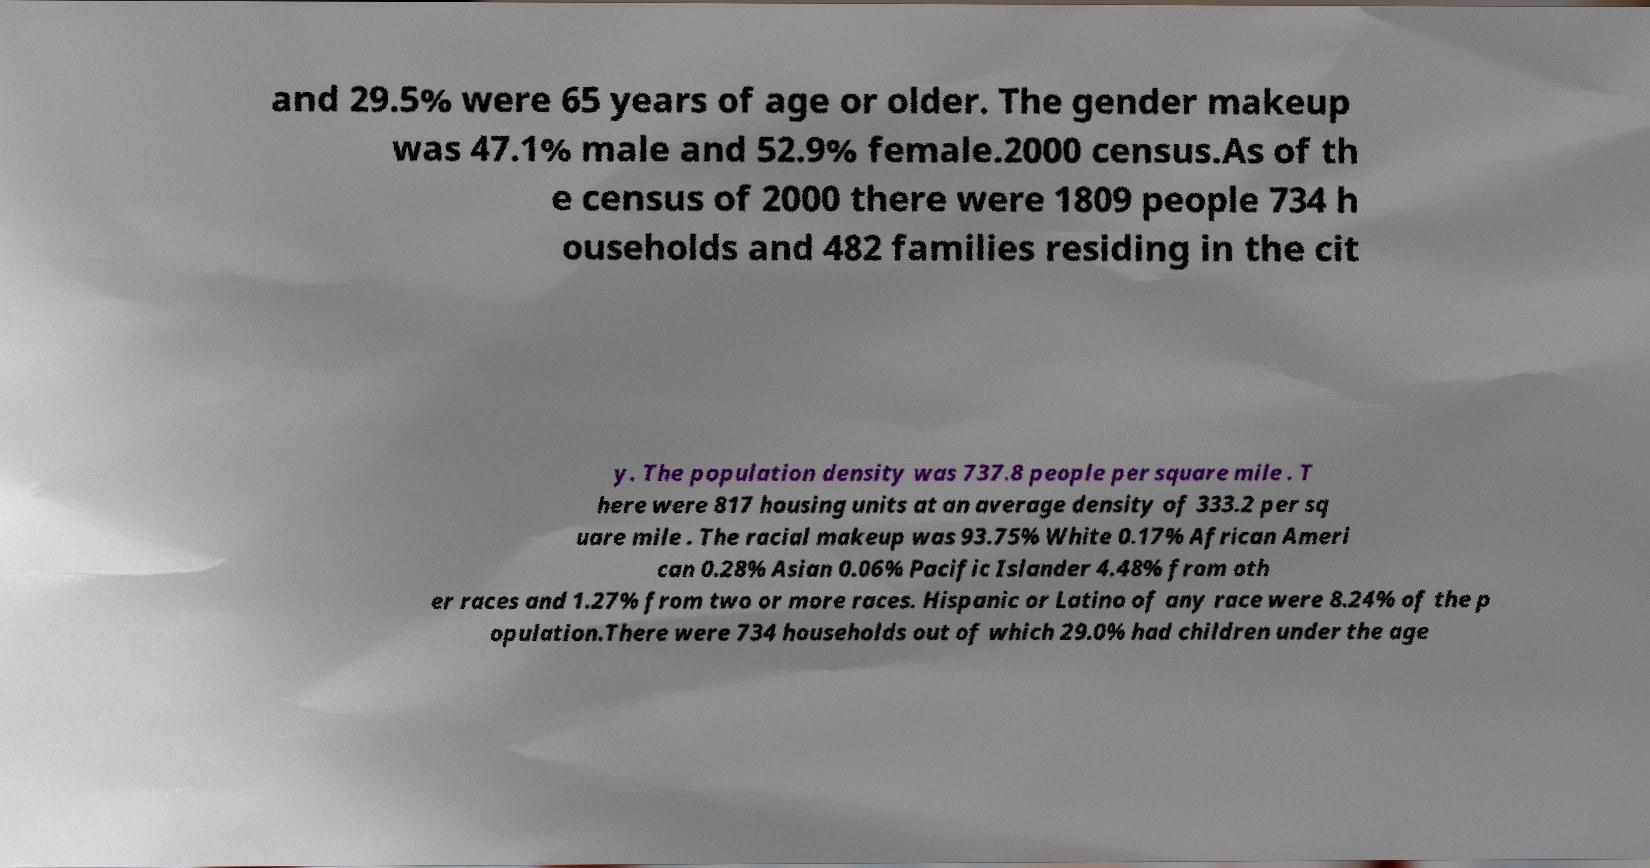I need the written content from this picture converted into text. Can you do that? and 29.5% were 65 years of age or older. The gender makeup was 47.1% male and 52.9% female.2000 census.As of th e census of 2000 there were 1809 people 734 h ouseholds and 482 families residing in the cit y. The population density was 737.8 people per square mile . T here were 817 housing units at an average density of 333.2 per sq uare mile . The racial makeup was 93.75% White 0.17% African Ameri can 0.28% Asian 0.06% Pacific Islander 4.48% from oth er races and 1.27% from two or more races. Hispanic or Latino of any race were 8.24% of the p opulation.There were 734 households out of which 29.0% had children under the age 